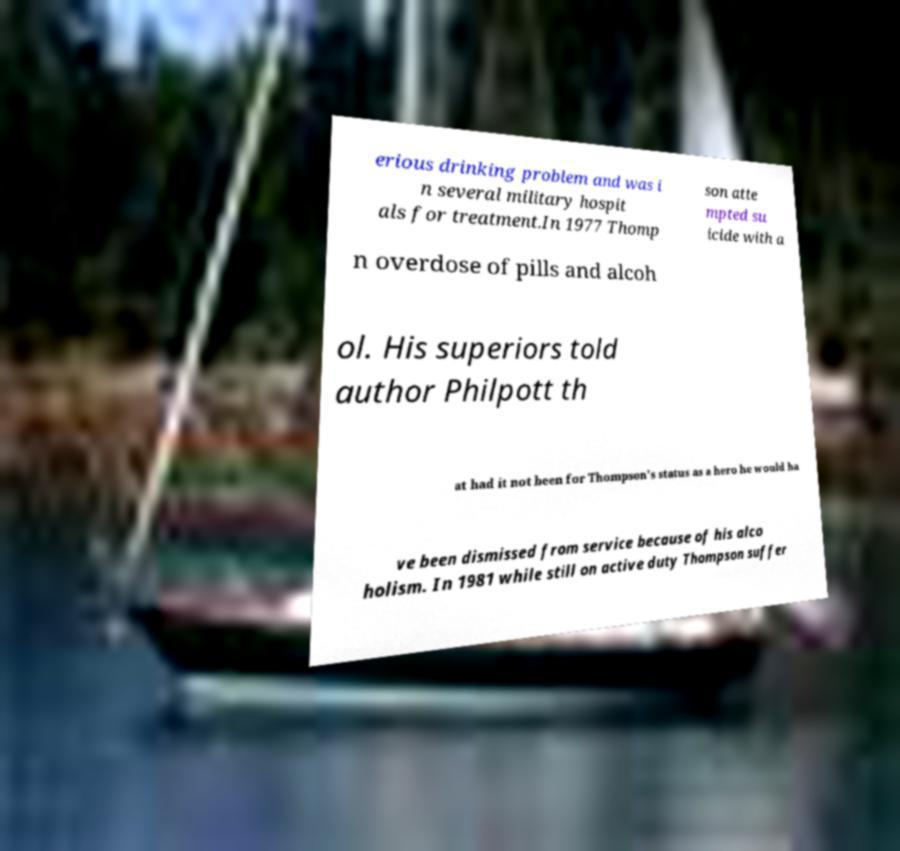I need the written content from this picture converted into text. Can you do that? erious drinking problem and was i n several military hospit als for treatment.In 1977 Thomp son atte mpted su icide with a n overdose of pills and alcoh ol. His superiors told author Philpott th at had it not been for Thompson's status as a hero he would ha ve been dismissed from service because of his alco holism. In 1981 while still on active duty Thompson suffer 